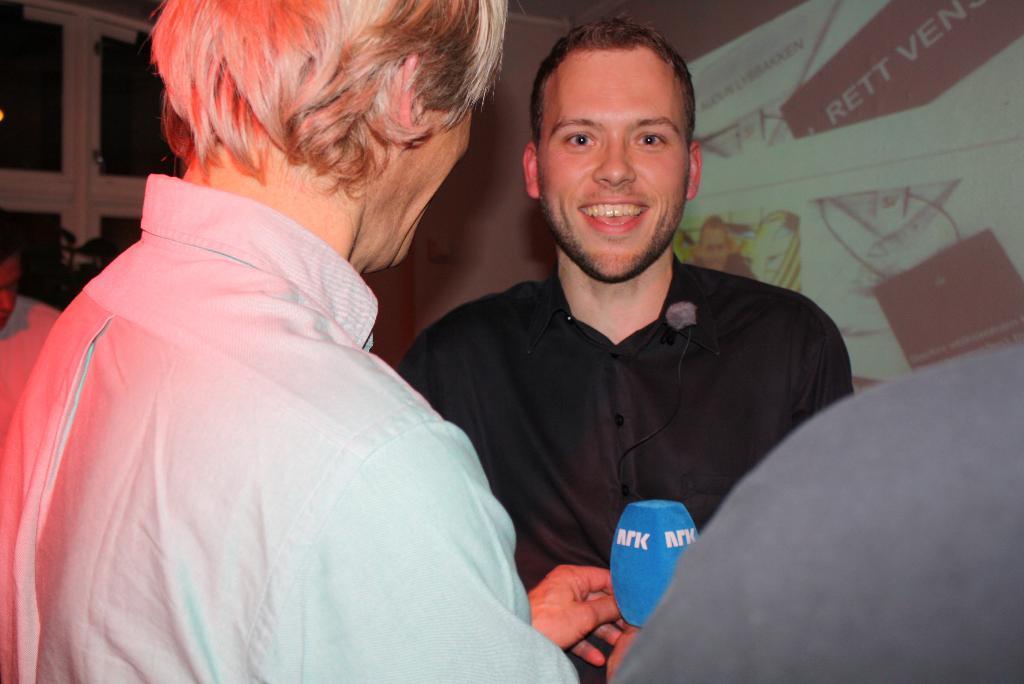In one or two sentences, can you explain what this image depicts? In the left side a man is there, he wore a shirt. in the right side there is another man smiling, he wore a black color shirt. 